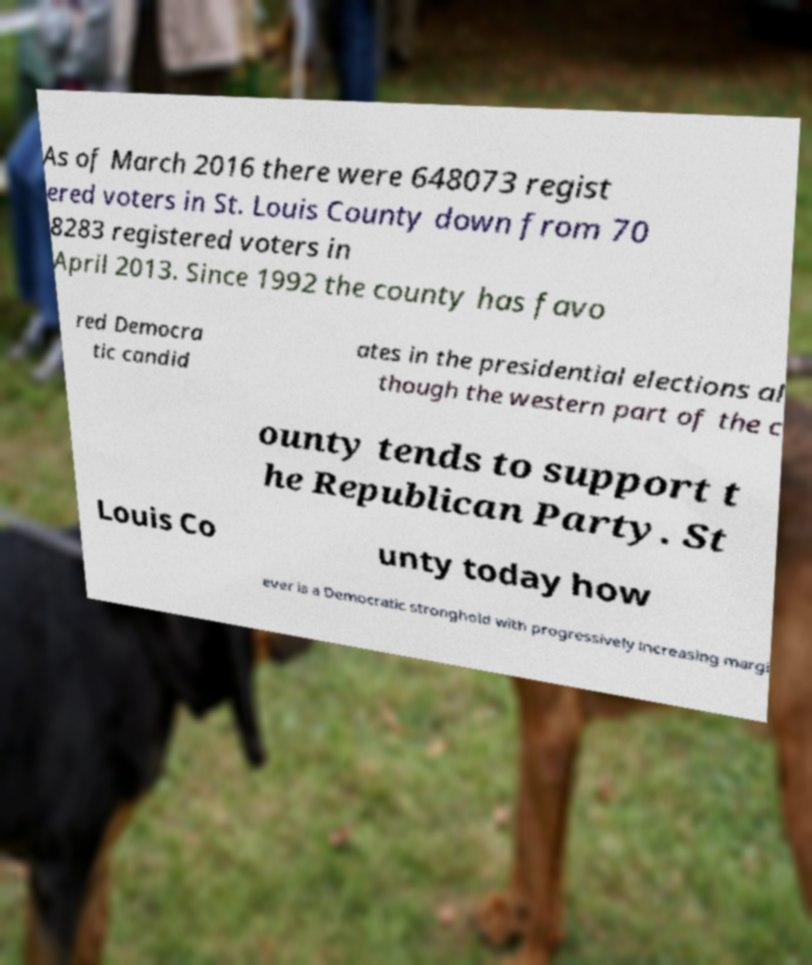What messages or text are displayed in this image? I need them in a readable, typed format. As of March 2016 there were 648073 regist ered voters in St. Louis County down from 70 8283 registered voters in April 2013. Since 1992 the county has favo red Democra tic candid ates in the presidential elections al though the western part of the c ounty tends to support t he Republican Party. St Louis Co unty today how ever is a Democratic stronghold with progressively increasing margi 